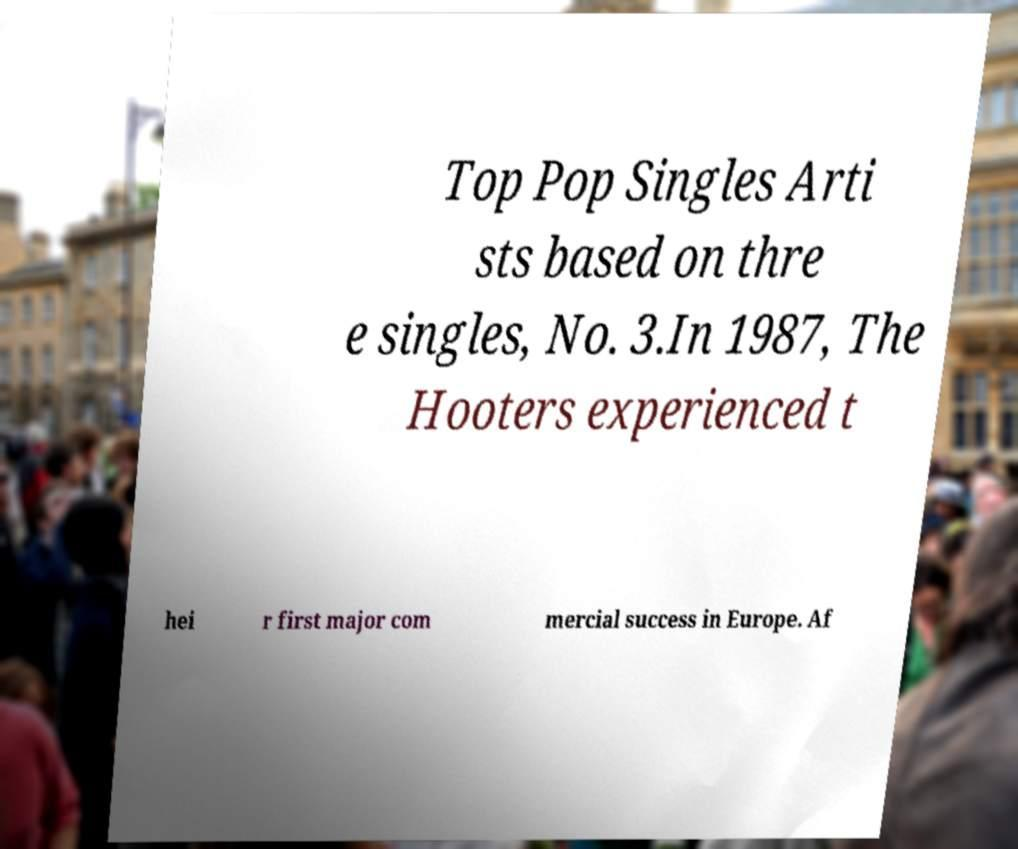Please identify and transcribe the text found in this image. Top Pop Singles Arti sts based on thre e singles, No. 3.In 1987, The Hooters experienced t hei r first major com mercial success in Europe. Af 